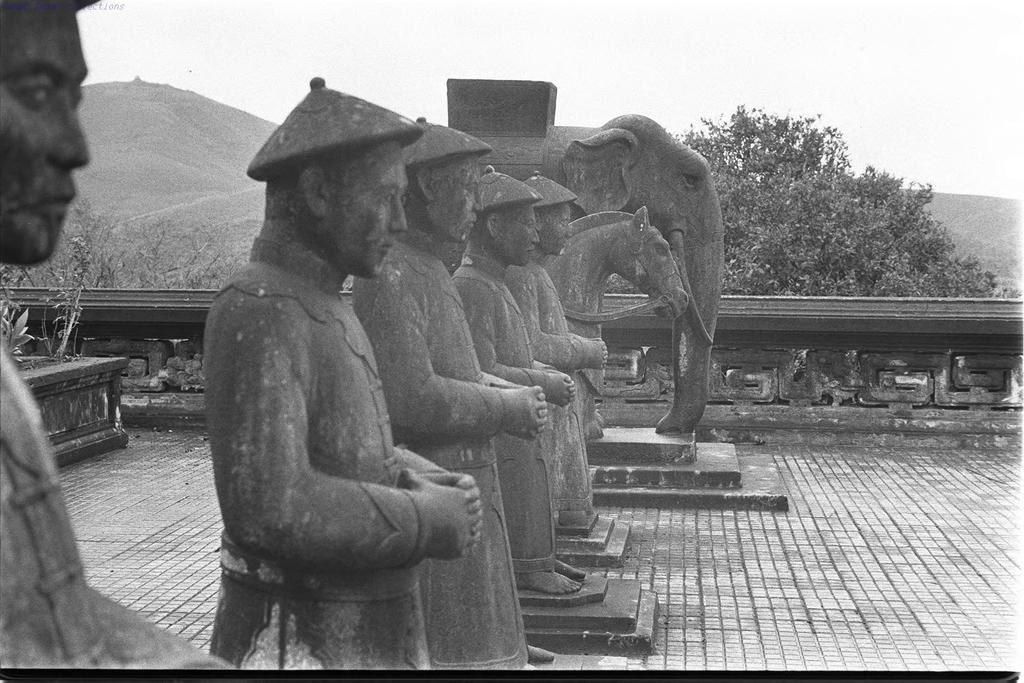What can be inferred about the age of the image? The image is old. What type of objects are depicted in the image? There are sculptures of people, a horse, and an elephant in the image. What is the background of the image? There are trees and mountains visible behind the sculptures. What type of fuel is being used by the jellyfish in the image? There are no jellyfish present in the image; it features sculptures of people, a horse, and an elephant. What type of art movement is depicted in the image? The image does not depict a specific art movement; it simply shows sculptures of people, a horse, and an elephant. 